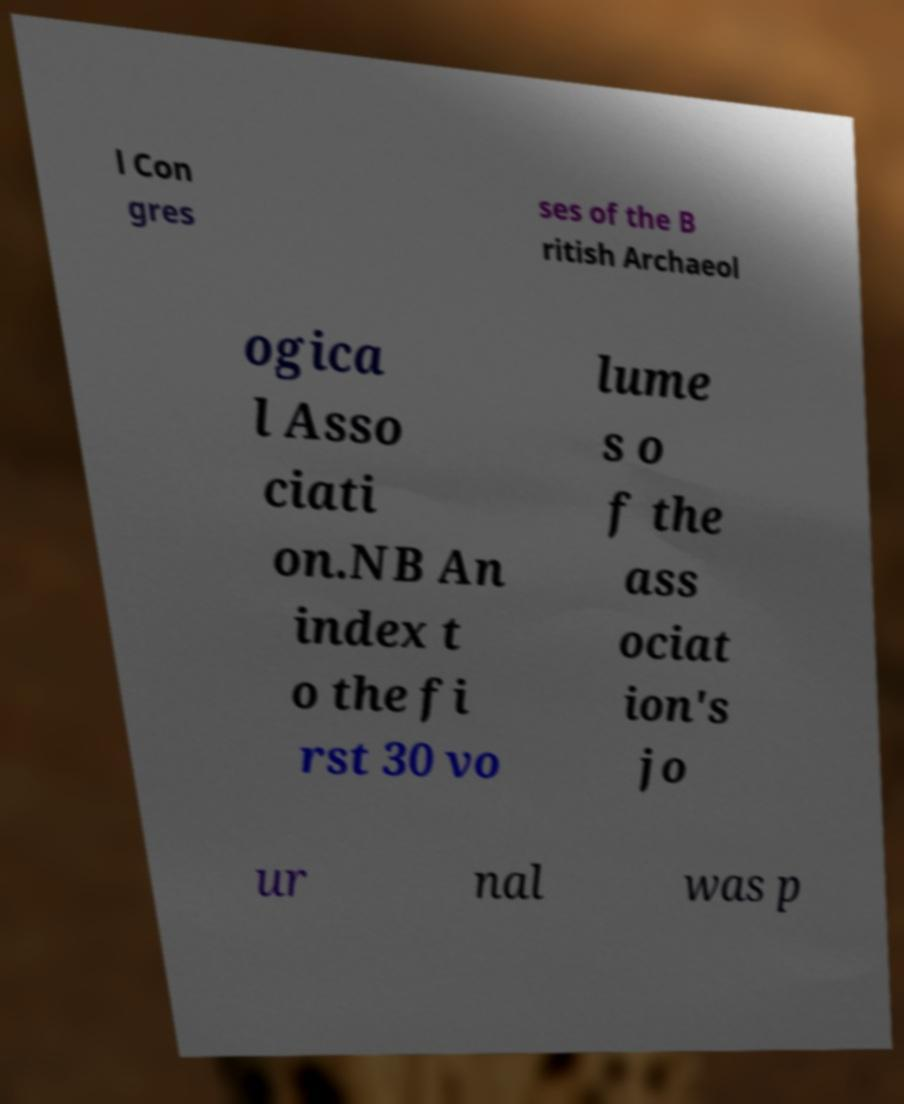I need the written content from this picture converted into text. Can you do that? l Con gres ses of the B ritish Archaeol ogica l Asso ciati on.NB An index t o the fi rst 30 vo lume s o f the ass ociat ion's jo ur nal was p 